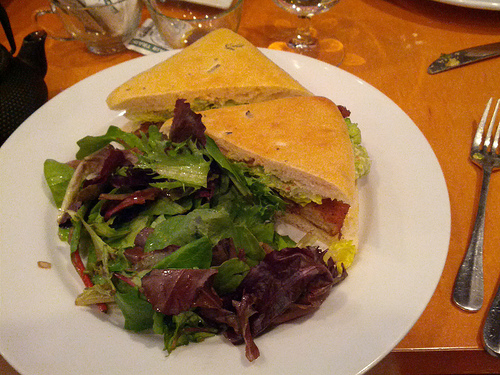Is the cup on the right? No, the cup is not on the right; it is located to the left side of the image. 